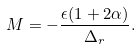Convert formula to latex. <formula><loc_0><loc_0><loc_500><loc_500>M = - \frac { \epsilon ( 1 + 2 \alpha ) } { \Delta _ { r } } .</formula> 